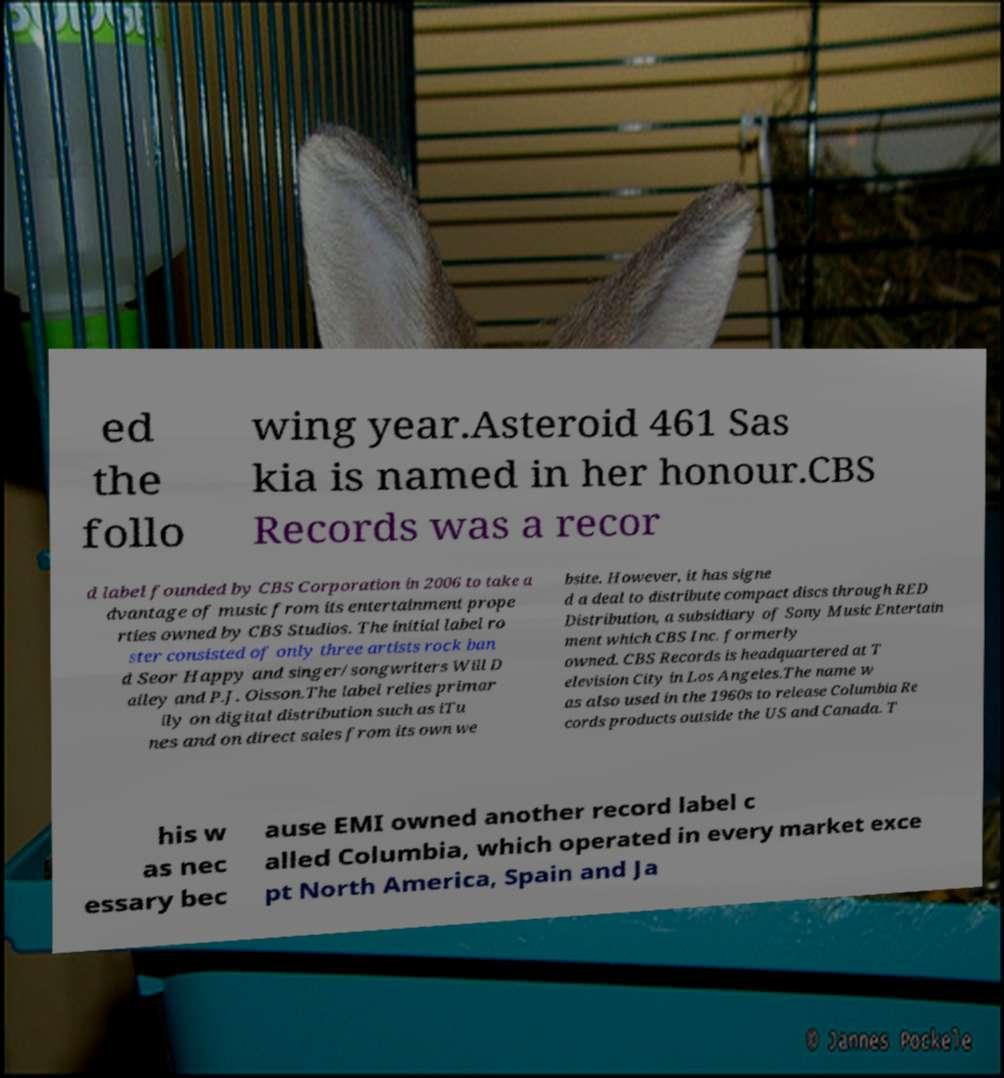Can you accurately transcribe the text from the provided image for me? ed the follo wing year.Asteroid 461 Sas kia is named in her honour.CBS Records was a recor d label founded by CBS Corporation in 2006 to take a dvantage of music from its entertainment prope rties owned by CBS Studios. The initial label ro ster consisted of only three artists rock ban d Seor Happy and singer/songwriters Will D ailey and P.J. Olsson.The label relies primar ily on digital distribution such as iTu nes and on direct sales from its own we bsite. However, it has signe d a deal to distribute compact discs through RED Distribution, a subsidiary of Sony Music Entertain ment which CBS Inc. formerly owned. CBS Records is headquartered at T elevision City in Los Angeles.The name w as also used in the 1960s to release Columbia Re cords products outside the US and Canada. T his w as nec essary bec ause EMI owned another record label c alled Columbia, which operated in every market exce pt North America, Spain and Ja 